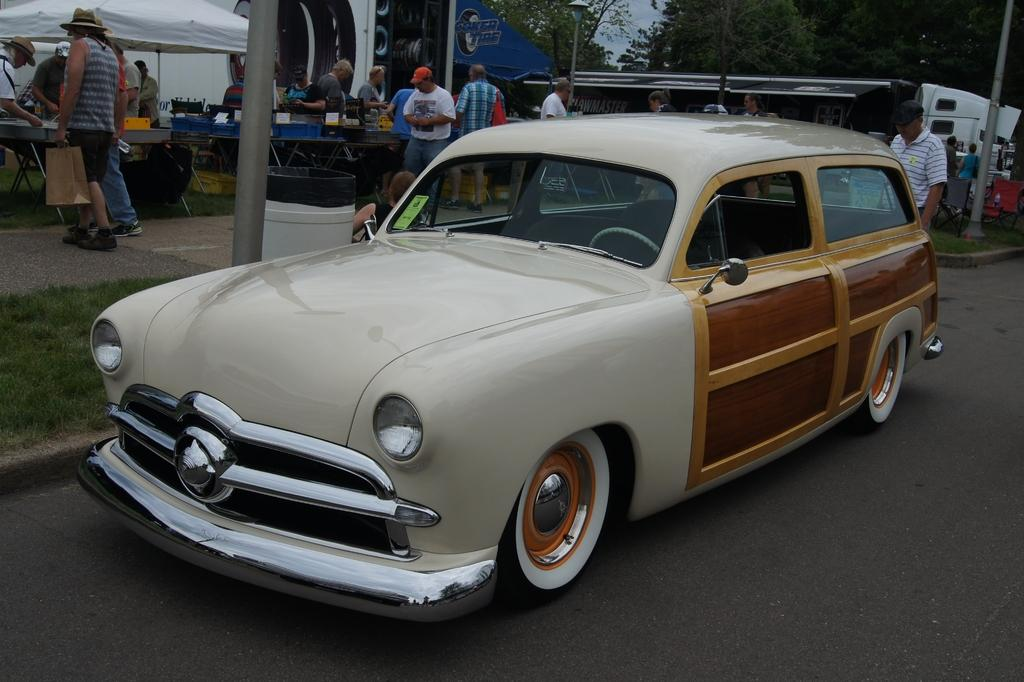What is the main subject of the image? There is a car on the road in the image. What can be seen in the background of the image? There are food quotes in the background of the image. What are the people in the image doing? People are doing different activities in the image. What type of vegetation is on the right side of the image? There are trees on the right side of the image. Can you tell me how many yokes are being used by the people in the image? There is no yoke present in the image, so it is not possible to determine how many are being used. What type of belief is depicted in the image? There is no specific belief depicted in the image; it features a car on the road, food quotes, people doing different activities, and trees. 